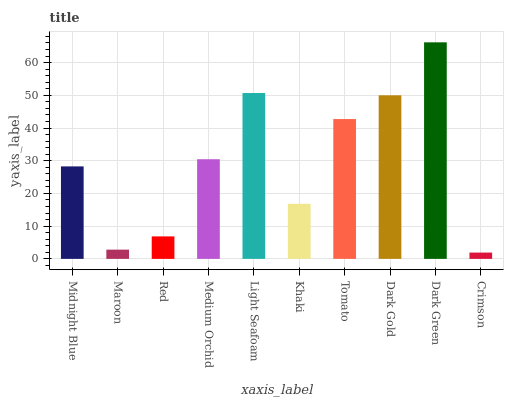Is Maroon the minimum?
Answer yes or no. No. Is Maroon the maximum?
Answer yes or no. No. Is Midnight Blue greater than Maroon?
Answer yes or no. Yes. Is Maroon less than Midnight Blue?
Answer yes or no. Yes. Is Maroon greater than Midnight Blue?
Answer yes or no. No. Is Midnight Blue less than Maroon?
Answer yes or no. No. Is Medium Orchid the high median?
Answer yes or no. Yes. Is Midnight Blue the low median?
Answer yes or no. Yes. Is Crimson the high median?
Answer yes or no. No. Is Maroon the low median?
Answer yes or no. No. 